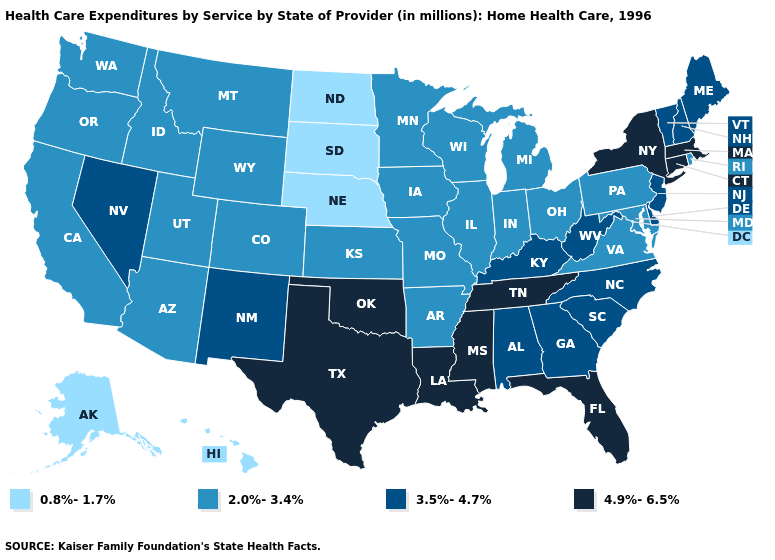Name the states that have a value in the range 4.9%-6.5%?
Answer briefly. Connecticut, Florida, Louisiana, Massachusetts, Mississippi, New York, Oklahoma, Tennessee, Texas. Name the states that have a value in the range 4.9%-6.5%?
Answer briefly. Connecticut, Florida, Louisiana, Massachusetts, Mississippi, New York, Oklahoma, Tennessee, Texas. Name the states that have a value in the range 4.9%-6.5%?
Write a very short answer. Connecticut, Florida, Louisiana, Massachusetts, Mississippi, New York, Oklahoma, Tennessee, Texas. Does Nevada have a higher value than Michigan?
Short answer required. Yes. Does the first symbol in the legend represent the smallest category?
Give a very brief answer. Yes. Does Maine have the lowest value in the USA?
Quick response, please. No. What is the value of Iowa?
Answer briefly. 2.0%-3.4%. What is the value of Pennsylvania?
Short answer required. 2.0%-3.4%. Name the states that have a value in the range 4.9%-6.5%?
Short answer required. Connecticut, Florida, Louisiana, Massachusetts, Mississippi, New York, Oklahoma, Tennessee, Texas. Name the states that have a value in the range 3.5%-4.7%?
Concise answer only. Alabama, Delaware, Georgia, Kentucky, Maine, Nevada, New Hampshire, New Jersey, New Mexico, North Carolina, South Carolina, Vermont, West Virginia. What is the value of North Carolina?
Short answer required. 3.5%-4.7%. What is the highest value in the West ?
Keep it brief. 3.5%-4.7%. What is the value of Nebraska?
Quick response, please. 0.8%-1.7%. What is the lowest value in the MidWest?
Concise answer only. 0.8%-1.7%. Is the legend a continuous bar?
Answer briefly. No. 